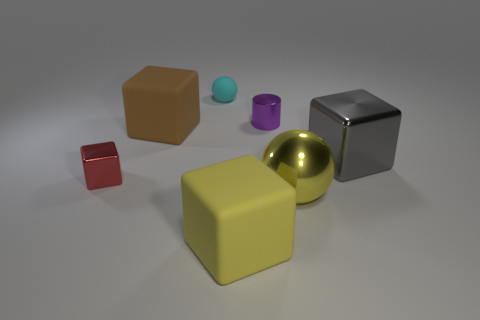Are there any large blocks of the same color as the large metal ball?
Your response must be concise. Yes. What is the color of the big block that is the same material as the purple cylinder?
Give a very brief answer. Gray. Are the tiny cylinder and the gray cube in front of the tiny shiny cylinder made of the same material?
Make the answer very short. Yes. The thing that is behind the small red cube and on the left side of the cyan rubber object is what color?
Make the answer very short. Brown. How many cubes are tiny red objects or large rubber objects?
Give a very brief answer. 3. Does the red object have the same shape as the big yellow thing that is on the left side of the purple metallic object?
Provide a short and direct response. Yes. There is a metallic thing that is both left of the large ball and on the right side of the small red object; what is its size?
Keep it short and to the point. Small. What shape is the tiny cyan matte object?
Your answer should be very brief. Sphere. There is a big rubber object behind the red object; are there any purple objects that are behind it?
Your answer should be compact. Yes. There is a big yellow thing behind the large yellow cube; how many brown matte things are to the right of it?
Give a very brief answer. 0. 